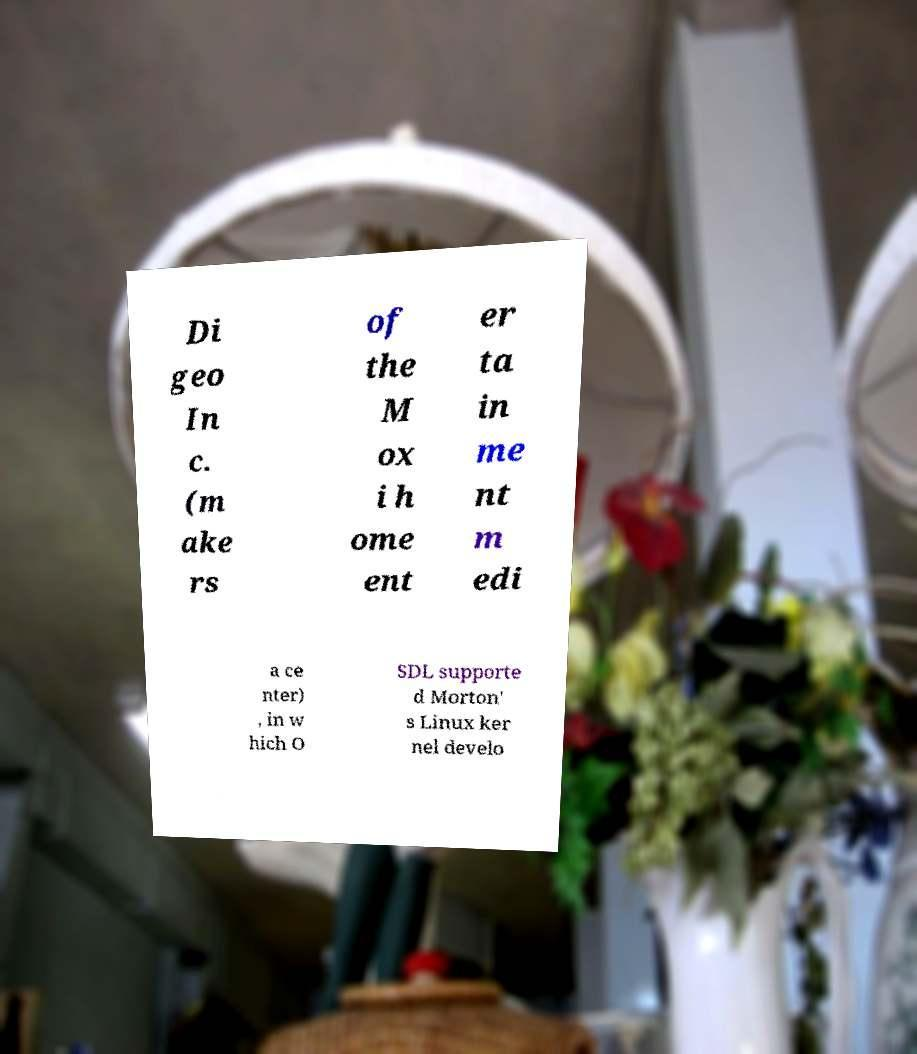Could you assist in decoding the text presented in this image and type it out clearly? Di geo In c. (m ake rs of the M ox i h ome ent er ta in me nt m edi a ce nter) , in w hich O SDL supporte d Morton' s Linux ker nel develo 